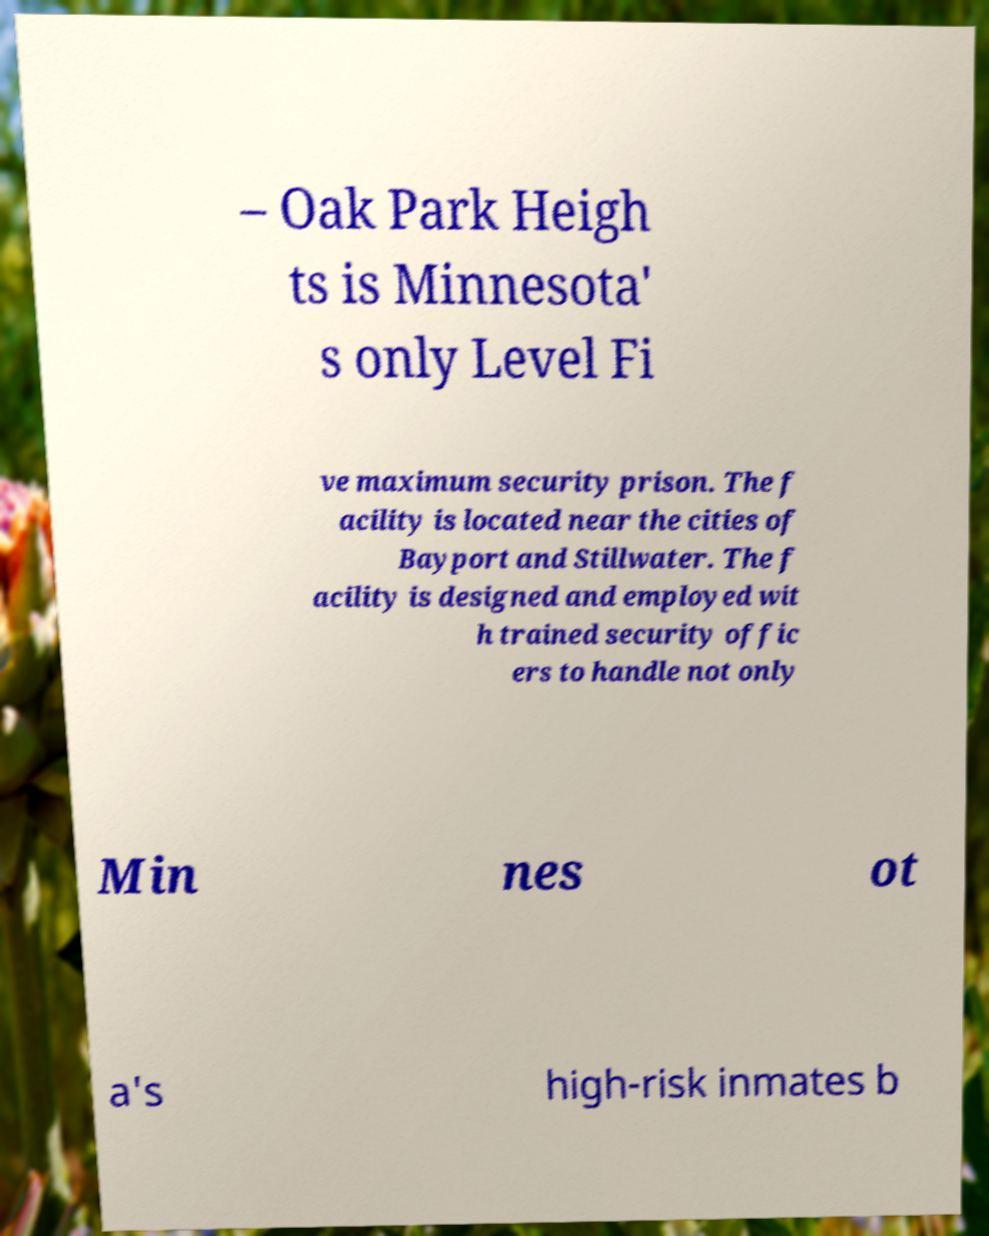What messages or text are displayed in this image? I need them in a readable, typed format. – Oak Park Heigh ts is Minnesota' s only Level Fi ve maximum security prison. The f acility is located near the cities of Bayport and Stillwater. The f acility is designed and employed wit h trained security offic ers to handle not only Min nes ot a's high-risk inmates b 